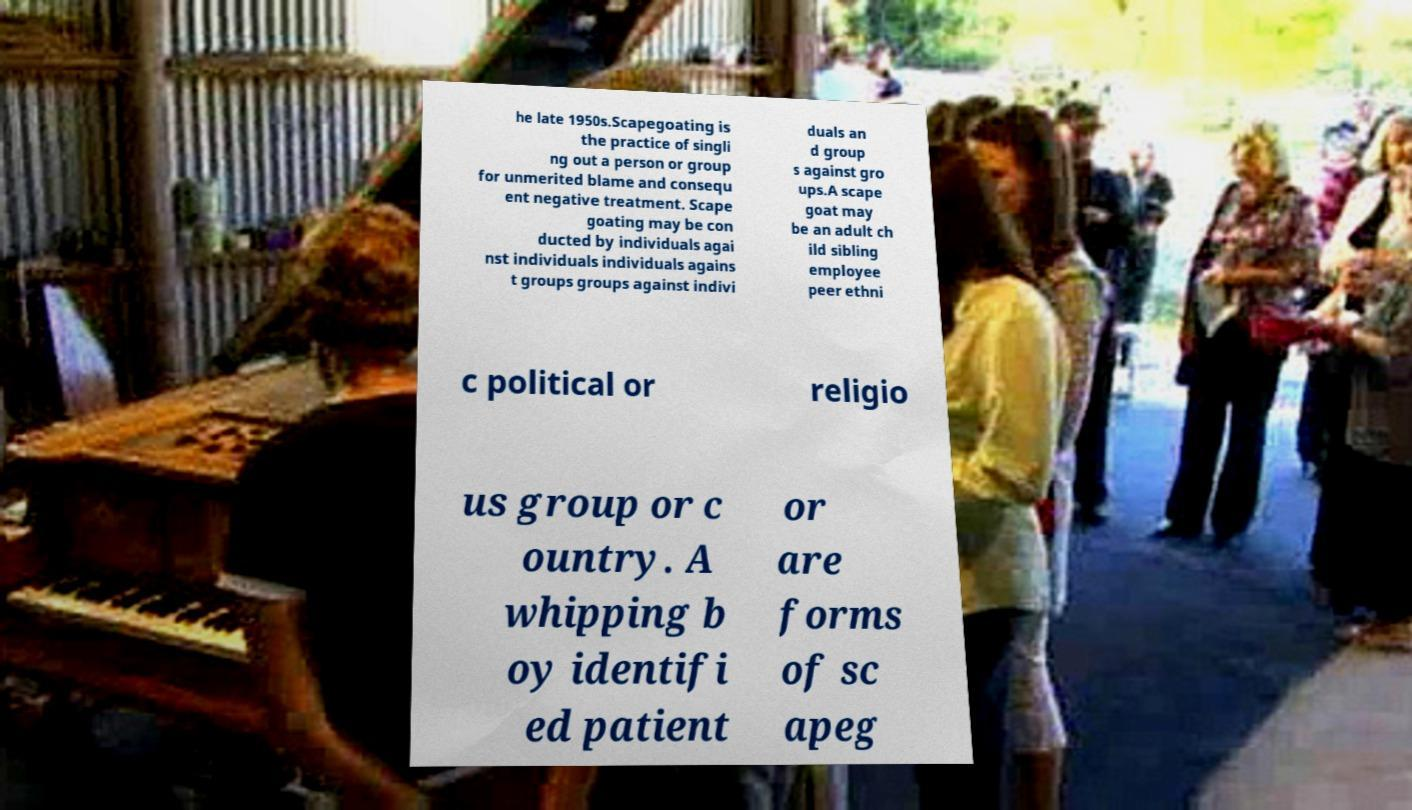Please read and relay the text visible in this image. What does it say? he late 1950s.Scapegoating is the practice of singli ng out a person or group for unmerited blame and consequ ent negative treatment. Scape goating may be con ducted by individuals agai nst individuals individuals agains t groups groups against indivi duals an d group s against gro ups.A scape goat may be an adult ch ild sibling employee peer ethni c political or religio us group or c ountry. A whipping b oy identifi ed patient or are forms of sc apeg 